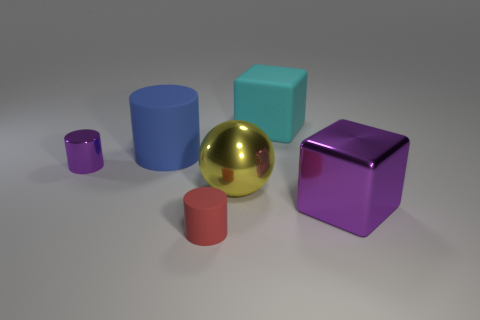Subtract 1 cylinders. How many cylinders are left? 2 Add 1 metallic things. How many objects exist? 7 Subtract all blocks. How many objects are left? 4 Subtract 0 yellow cubes. How many objects are left? 6 Subtract all brown matte cubes. Subtract all cyan things. How many objects are left? 5 Add 1 large blue matte cylinders. How many large blue matte cylinders are left? 2 Add 4 metallic spheres. How many metallic spheres exist? 5 